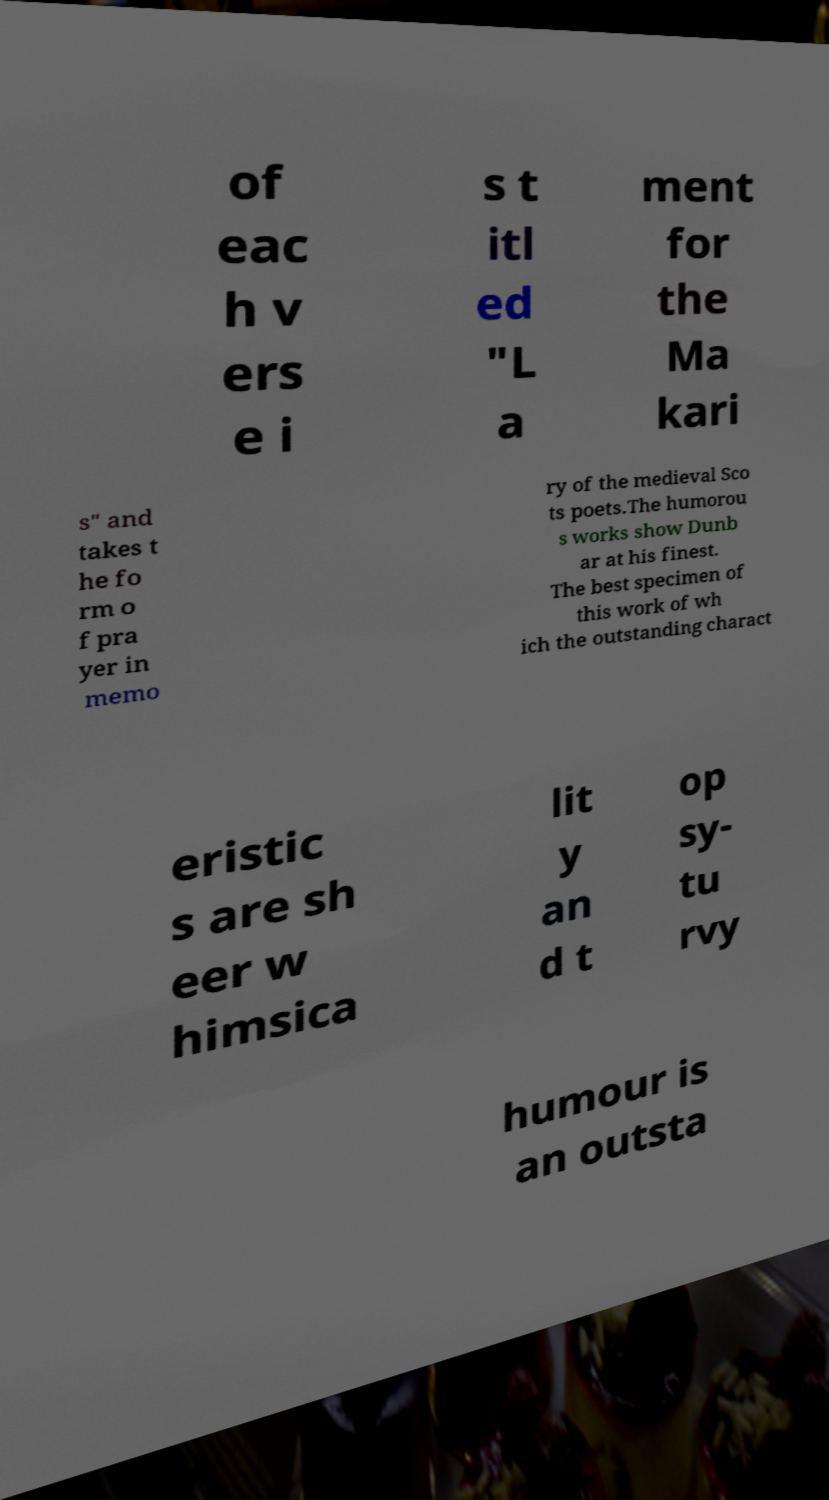Please identify and transcribe the text found in this image. of eac h v ers e i s t itl ed "L a ment for the Ma kari s" and takes t he fo rm o f pra yer in memo ry of the medieval Sco ts poets.The humorou s works show Dunb ar at his finest. The best specimen of this work of wh ich the outstanding charact eristic s are sh eer w himsica lit y an d t op sy- tu rvy humour is an outsta 